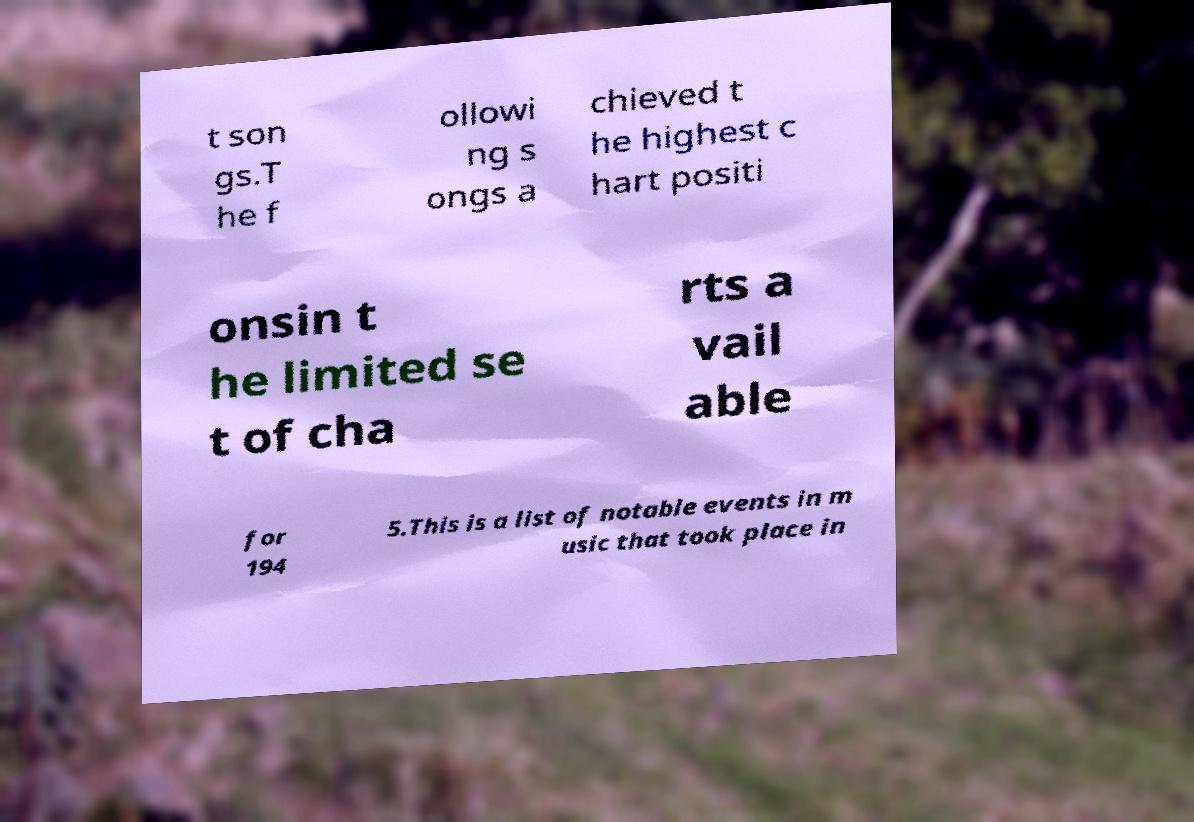Could you extract and type out the text from this image? t son gs.T he f ollowi ng s ongs a chieved t he highest c hart positi onsin t he limited se t of cha rts a vail able for 194 5.This is a list of notable events in m usic that took place in 